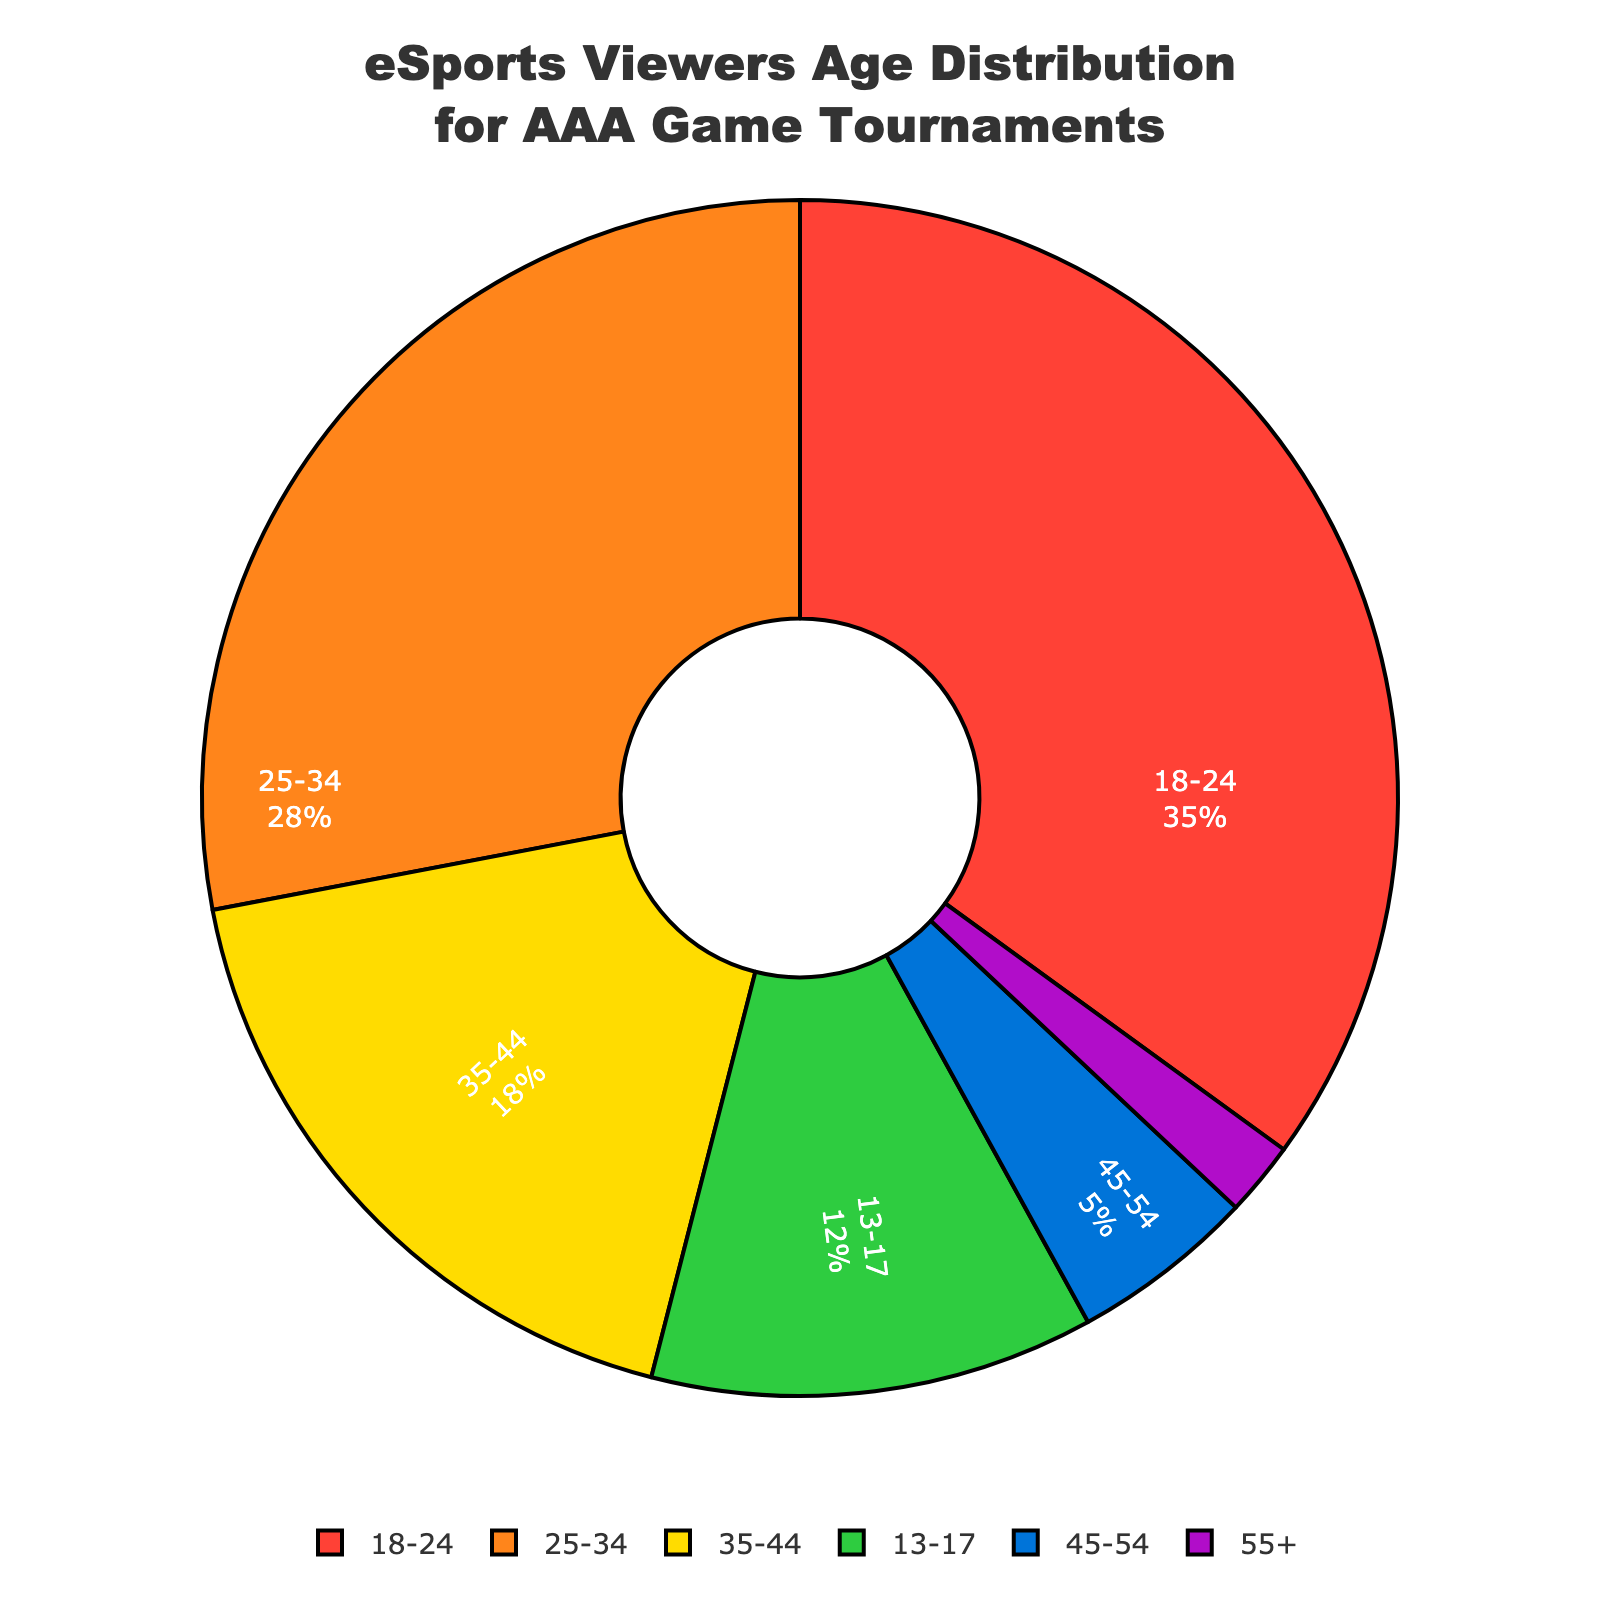Which age group has the highest percentage of eSports viewers for AAA game tournaments? Look at the age group with the largest slice in the pie chart. The 18-24 age group has the largest slice, thus the highest percentage.
Answer: 18-24 Which age group has the smallest percentage of eSports viewers for AAA game tournaments? Look at the age group with the smallest slice in the pie chart. The 55+ age group has the smallest slice, thus the smallest percentage.
Answer: 55+ What is the total percentage of viewers aged between 13 and 34? Add the percentages of the 13-17, 18-24, and 25-34 age groups. 12% (13-17) + 35% (18-24) + 28% (25-34) = 75%.
Answer: 75% How much greater is the percentage of viewers aged 25-34 compared to those aged 45-54? Subtract the percentage of the 45-54 age group from the percentage of the 25-34 age group. 28% (25-34) - 5% (45-54) = 23%.
Answer: 23% What is the average percentage of viewers in the 35-44, 45-54, and 55+ age groups? Add the percentages of 35-44, 45-54, and 55+ and divide by 3. (18% + 5% + 2%) / 3 = 25% / 3 ≈ 8.33%.
Answer: 8.33% Which age group has a lower percentage of viewers than both the 35-44 and 13-17 age groups combined? The combined percentage of 35-44 and 13-17 is 18% + 12% = 30%. The only age groups below this percentage are 45-54 and 55+.
Answer: 45-54, 55+ Are there more viewers aged 13-17 or viewers aged 35-44? Compare the slices for the 13-17 and 35-44 age groups. The percentage for 35-44 is larger than for 13-17 (18% vs 12%).
Answer: 35-44 What color represents the 25-34 age group, and what is its percentage of the total pie? Look for the color and size of the slice labeled 25-34. The color is orange, and the percentage is 28%.
Answer: Orange, 28% Is there any age group representing exactly or nearly one-third of the total viewership? Check the slices to see if any represent around 33.33%. The largest slice, 18-24, is closest at 35%, which is slightly more than one-third.
Answer: 18-24, 35% Which two adjacent age groups combined make up more than half of the viewers? Check combinations of adjacent slices. The 13-17 + 18-24 (12% + 35% = 47%) and 18-24 + 25-34 (35% + 28% = 63%) combinations are adjacent, but only the latter exceeds half.
Answer: 18-24 and 25-34, 63% 